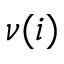<formula> <loc_0><loc_0><loc_500><loc_500>\nu ( i )</formula> 